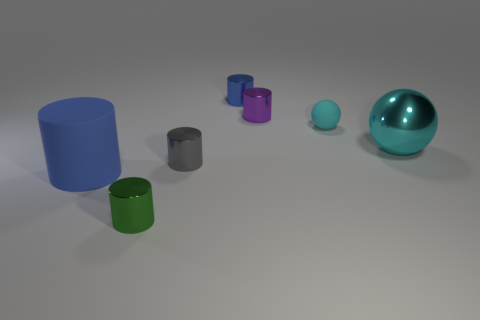What is the size of the cylinder that is both right of the tiny green cylinder and in front of the tiny purple metal cylinder?
Keep it short and to the point. Small. There is a metallic cylinder that is on the right side of the tiny green metallic cylinder and in front of the big cyan object; what color is it?
Offer a very short reply. Gray. Are there fewer cyan matte balls that are left of the purple metallic cylinder than small blue metal cylinders that are in front of the tiny green shiny cylinder?
Provide a succinct answer. No. What number of tiny cyan matte things are the same shape as the cyan metal thing?
Give a very brief answer. 1. The cyan thing that is made of the same material as the green object is what size?
Your response must be concise. Large. The object that is right of the sphere that is behind the large cyan metallic ball is what color?
Offer a very short reply. Cyan. There is a cyan metal thing; does it have the same shape as the matte object that is on the right side of the blue shiny object?
Ensure brevity in your answer.  Yes. What number of gray cylinders have the same size as the purple metal cylinder?
Offer a very short reply. 1. There is a big blue object that is the same shape as the tiny gray metallic thing; what is its material?
Provide a succinct answer. Rubber. Is the color of the matte object on the right side of the green metal cylinder the same as the large thing right of the matte cylinder?
Offer a terse response. Yes. 